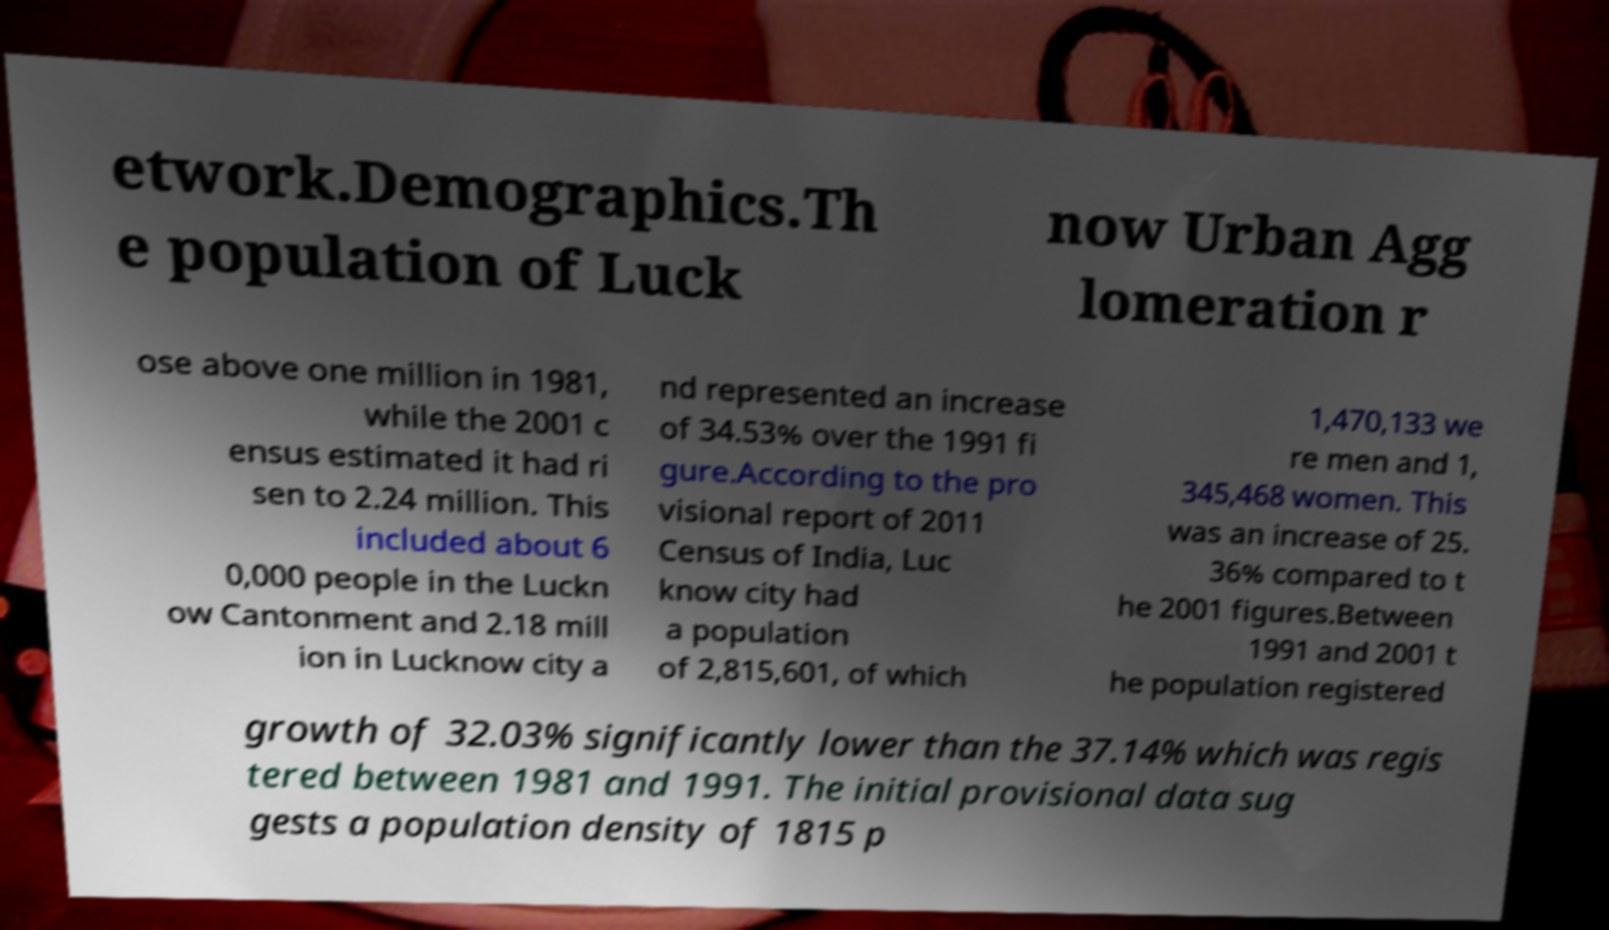Please read and relay the text visible in this image. What does it say? etwork.Demographics.Th e population of Luck now Urban Agg lomeration r ose above one million in 1981, while the 2001 c ensus estimated it had ri sen to 2.24 million. This included about 6 0,000 people in the Luckn ow Cantonment and 2.18 mill ion in Lucknow city a nd represented an increase of 34.53% over the 1991 fi gure.According to the pro visional report of 2011 Census of India, Luc know city had a population of 2,815,601, of which 1,470,133 we re men and 1, 345,468 women. This was an increase of 25. 36% compared to t he 2001 figures.Between 1991 and 2001 t he population registered growth of 32.03% significantly lower than the 37.14% which was regis tered between 1981 and 1991. The initial provisional data sug gests a population density of 1815 p 